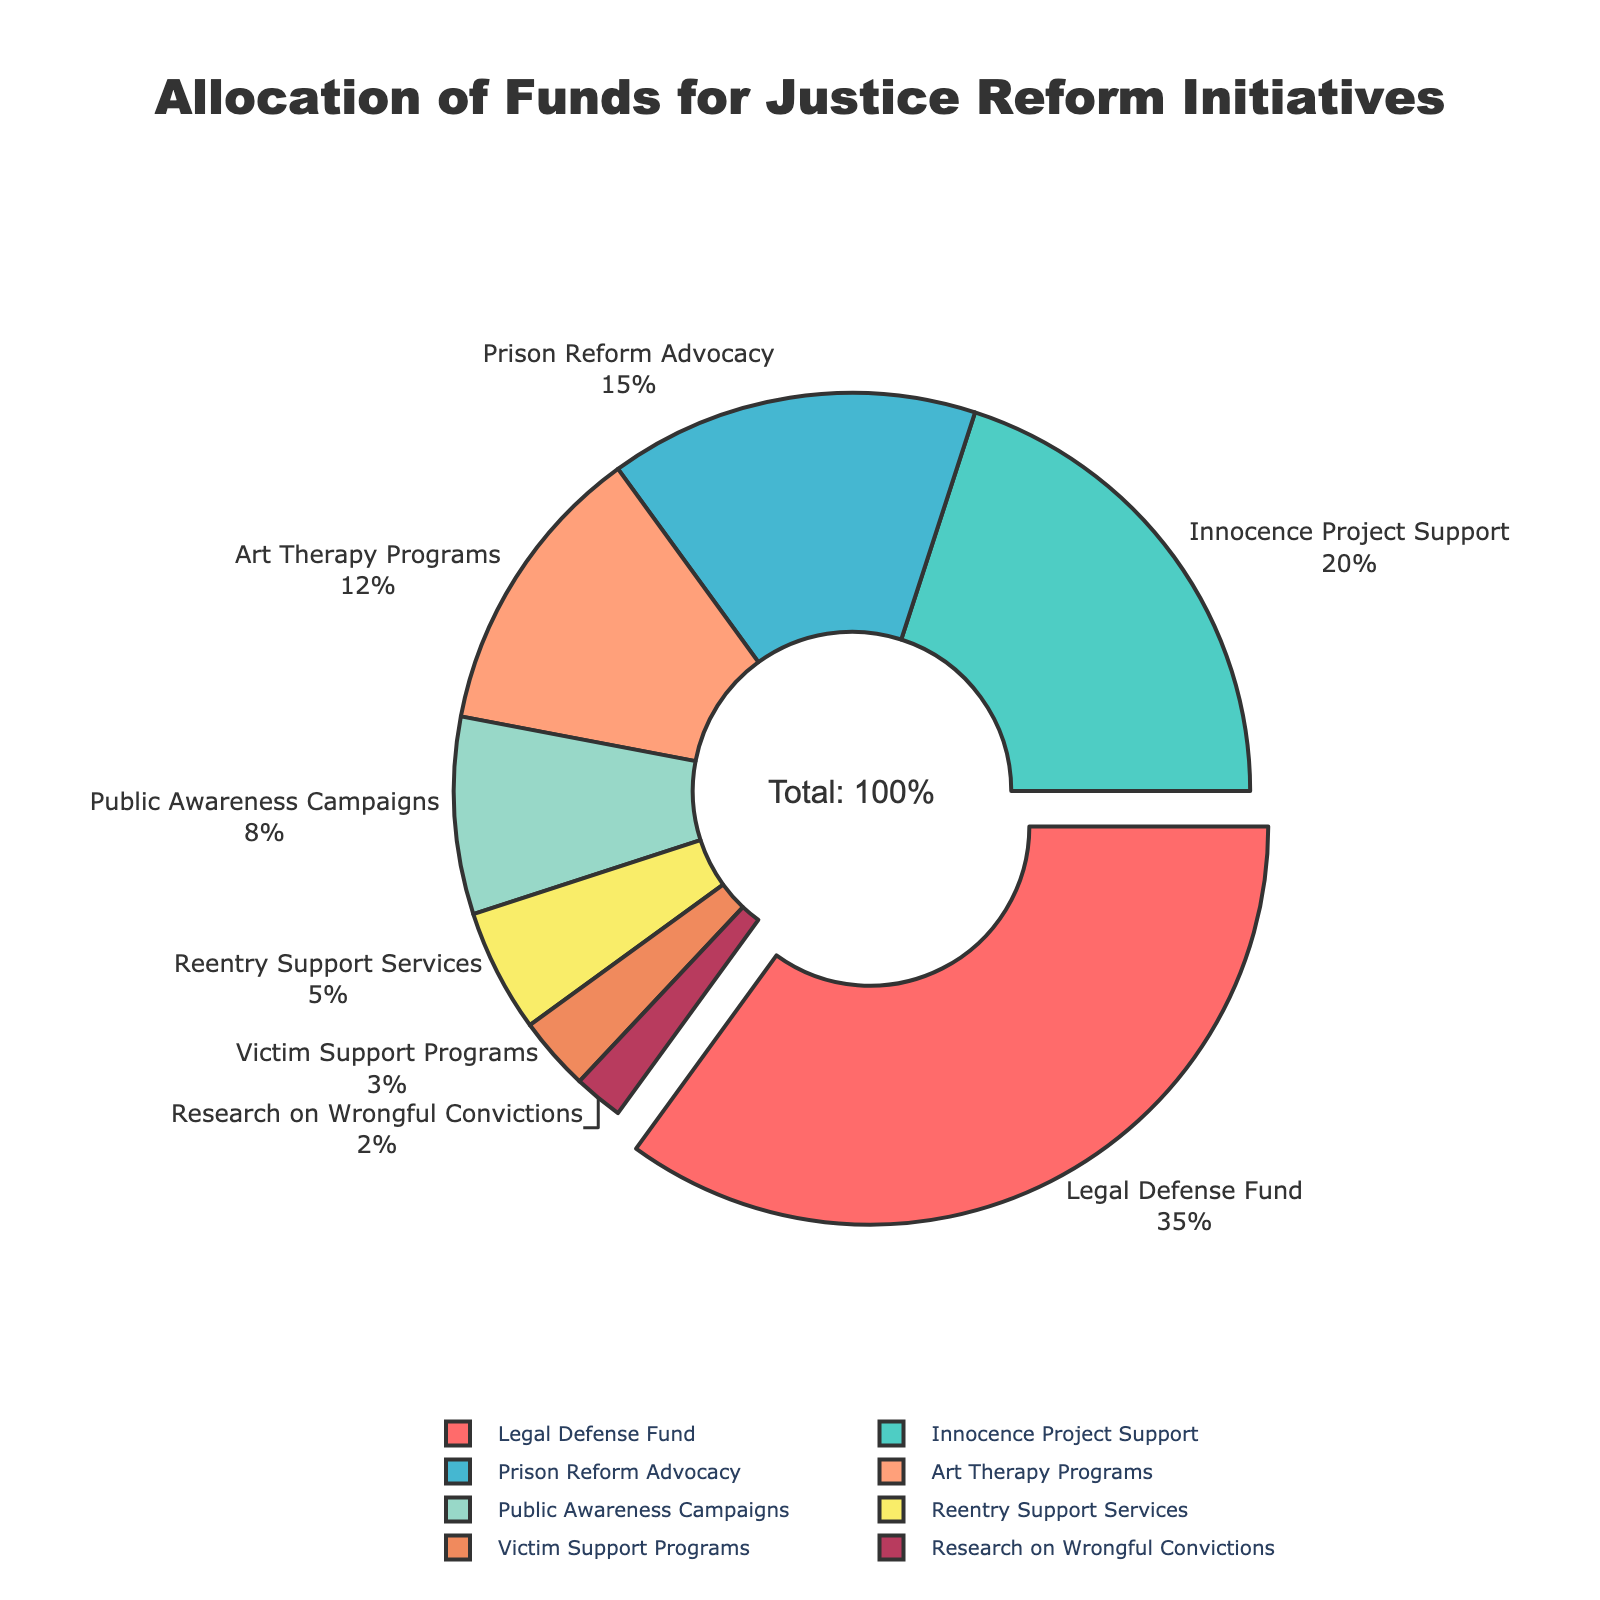What's the largest category in allocation of funds? The largest category is visually indicated by the segment pulled out from the pie chart and is clearly labeled "Legal Defense Fund" with a larger percentage compared to other segments.
Answer: Legal Defense Fund Which category has the smallest allocation? The smallest segment in the pie chart is visually smaller than the others and is labeled "Research on Wrongful Convictions" with the smallest percentage.
Answer: Research on Wrongful Convictions Compare the allocation percentage for Art Therapy Programs and Public Awareness Campaigns. Which is larger? By looking at the size of the pie chart segments, Art Therapy Programs has a larger percentage than Public Awareness Campaigns.
Answer: Art Therapy Programs What is the combined percentage for Legal Defense Fund and Innocence Project Support? The percentages for Legal Defense Fund and Innocence Project Support are 35% and 20%. Summing these, 35% + 20% = 55%.
Answer: 55% How much more percentage is allocated to Prison Reform Advocacy compared to Victim Support Programs? Subtract the percentage of the smaller segment from the larger one: Prison Reform Advocacy (15%) - Victim Support Programs (3%) = 12%.
Answer: 12% If we combine funds allocated to Public Awareness Campaigns and Reentry Support Services, what percentage of the total funds is this? Add the percentages: Public Awareness Campaigns (8%) + Reentry Support Services (5%) = 13%.
Answer: 13% What percentage of the total funds is allocated to the top three categories? The top three categories are Legal Defense Fund (35%), Innocence Project Support (20%), and Prison Reform Advocacy (15%). Sum these percentages, 35% + 20% + 15% = 70%.
Answer: 70% Compare the total percentage allocated to categories directly supporting wrongfully convicted individuals (Legal Defense Fund, Innocence Project Support) to categories supporting broader advocacy (Prison Reform Advocacy, Public Awareness Campaigns). Which is greater? Sum the percentages for each group: Directly supporting individuals: Legal Defense Fund (35%) + Innocence Project Support (20%) = 55%. Broader advocacy: Prison Reform Advocacy (15%) + Public Awareness Campaigns (8%) = 23%. Comparing 55% and 23%, the support for individuals is greater.
Answer: Support for individuals How much percentage in total is allocated to categories with less than 10% allocation each? Identify categories with less than 10% and sum their percentages: Public Awareness Campaigns (8%), Reentry Support Services (5%), Victim Support Programs (3%), Research on Wrongful Convictions (2%). Summing these, 8% + 5% + 3% + 2% = 18%.
Answer: 18% What is the difference between the percentages allocated to Art Therapy Programs and Research on Wrongful Convictions? Subtract the smaller percentage from the larger one: Art Therapy Programs (12%) - Research on Wrongful Convictions (2%) = 10%.
Answer: 10% 